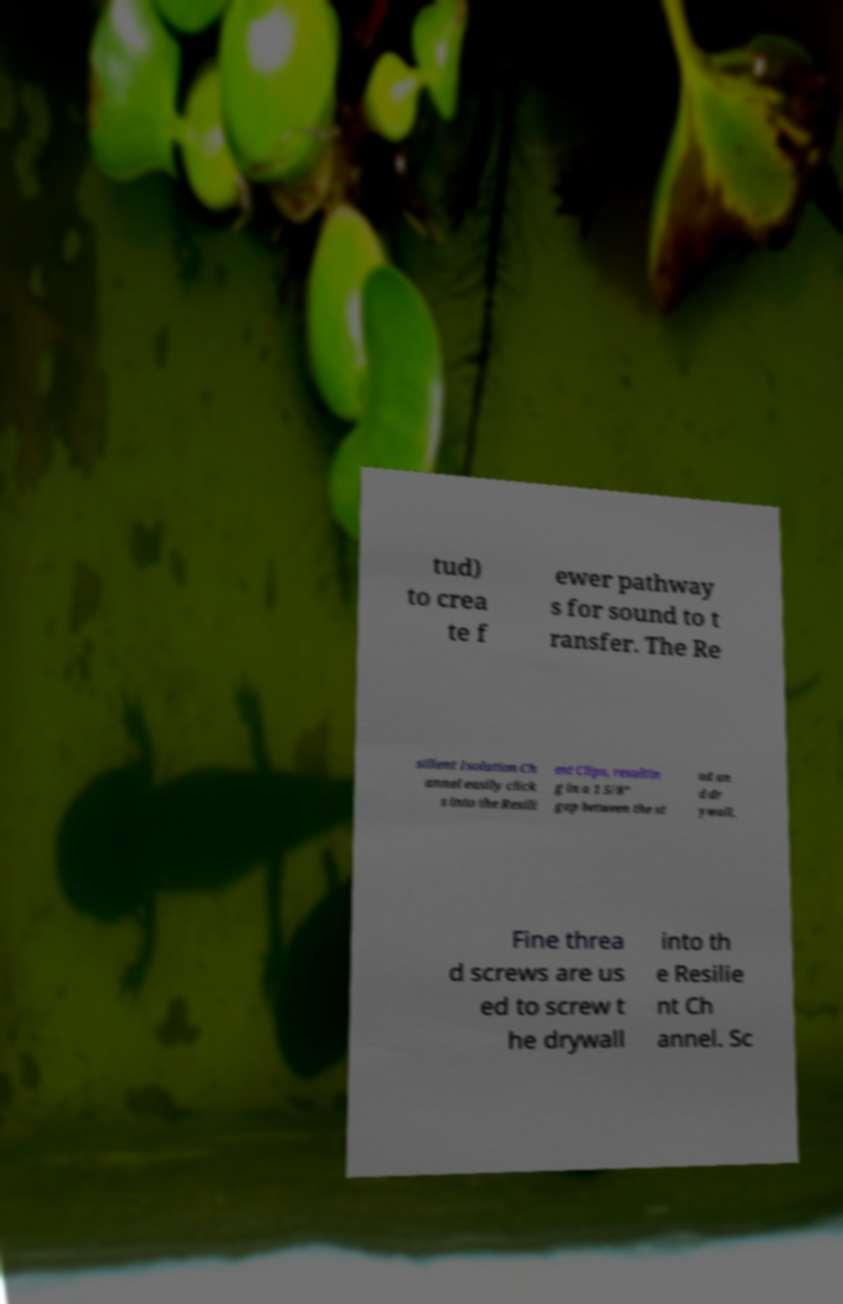Please identify and transcribe the text found in this image. tud) to crea te f ewer pathway s for sound to t ransfer. The Re silient Isolation Ch annel easily click s into the Resili ent Clips, resultin g in a 1 5/8” gap between the st ud an d dr ywall. Fine threa d screws are us ed to screw t he drywall into th e Resilie nt Ch annel. Sc 